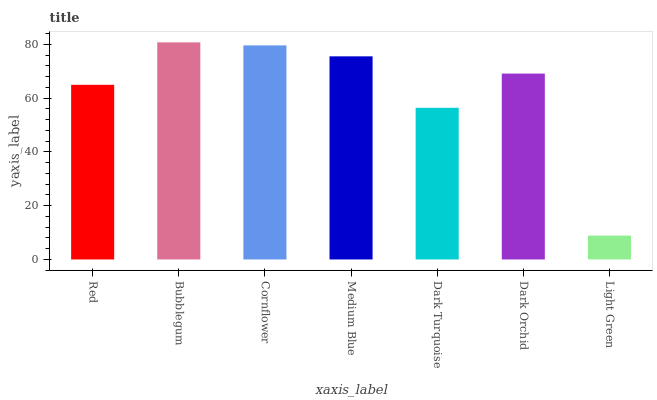Is Light Green the minimum?
Answer yes or no. Yes. Is Bubblegum the maximum?
Answer yes or no. Yes. Is Cornflower the minimum?
Answer yes or no. No. Is Cornflower the maximum?
Answer yes or no. No. Is Bubblegum greater than Cornflower?
Answer yes or no. Yes. Is Cornflower less than Bubblegum?
Answer yes or no. Yes. Is Cornflower greater than Bubblegum?
Answer yes or no. No. Is Bubblegum less than Cornflower?
Answer yes or no. No. Is Dark Orchid the high median?
Answer yes or no. Yes. Is Dark Orchid the low median?
Answer yes or no. Yes. Is Dark Turquoise the high median?
Answer yes or no. No. Is Dark Turquoise the low median?
Answer yes or no. No. 